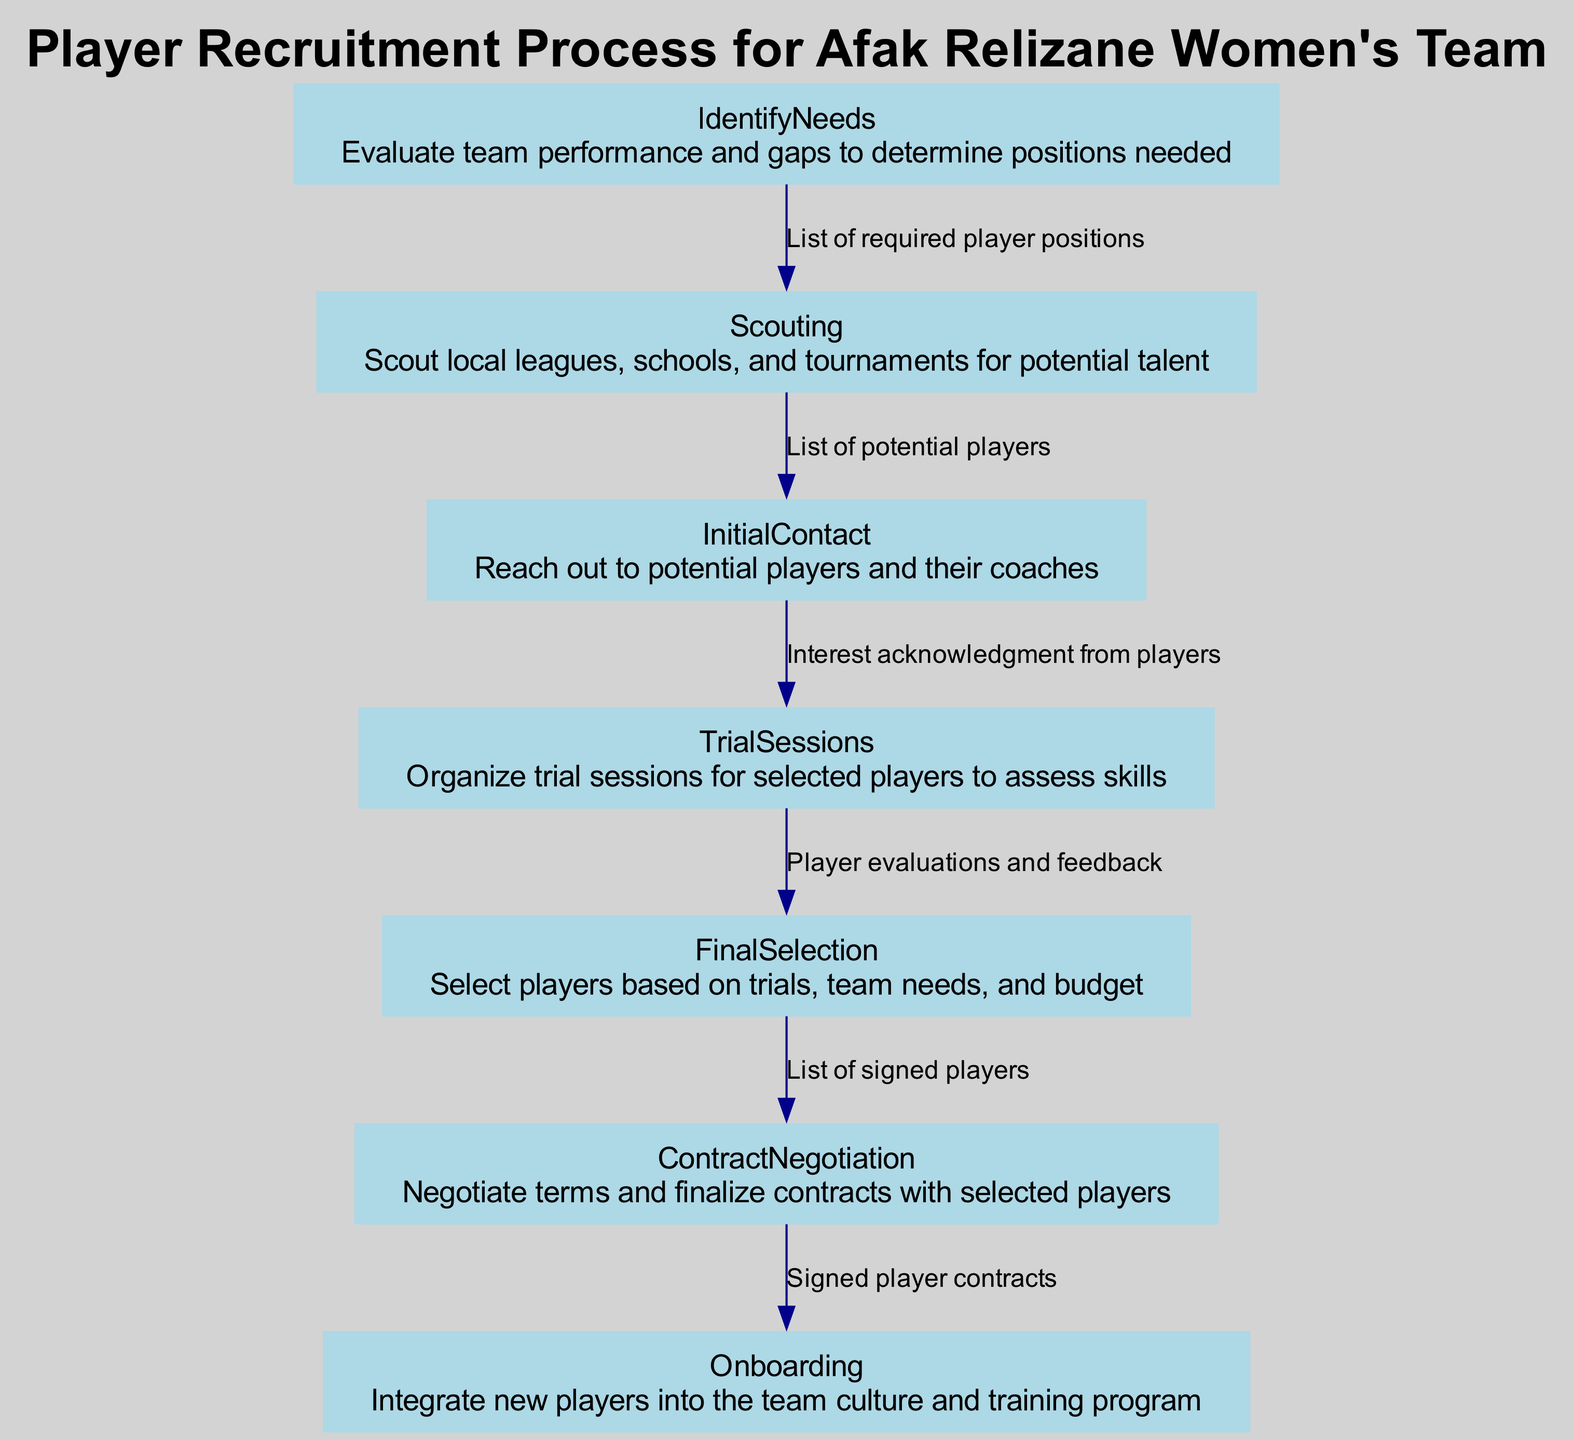what is the first step in the recruitment process? The flow chart begins with "IdentifyNeeds," which is the first step outlined in the player recruitment process.
Answer: IdentifyNeeds how many total steps are there in the recruitment process? By counting the nodes from "IdentifyNeeds" to "Onboarding," there are seven distinct steps in the recruitment process.
Answer: 7 which step comes after "Scouting"? According to the sequence in the flow chart, "InitialContact" is the step that follows "Scouting."
Answer: InitialContact what is the output of the "TrialSessions" step? The output is described as "Player evaluations and feedback," which directly follows the description of the "TrialSessions" step in the diagram.
Answer: Player evaluations and feedback which step is responsible for integrating new players? The step designated for this task is "Onboarding," as indicated in the flow chart.
Answer: Onboarding what is the overall last step in the recruitment process? The recruitment process culminates with "Onboarding," which is the final step shown in this flow chart.
Answer: Onboarding how does "FinalSelection" relate to "TrialSessions"? "FinalSelection" depends on the evaluations and feedback received from the preceding step, "TrialSessions," to select players based on trials, team needs, and budget.
Answer: FinalSelection what is the output of the "ContractNegotiation" step? The output is outlined as "Signed player contracts," indicating the result of the contract negotiation process with selected players.
Answer: Signed player contracts what is the purpose of the "InitialContact" step? The purpose of this step is to reach out to potential players and their coaches, indicated by the description associated with the "InitialContact" in the diagram.
Answer: Reach out to potential players and their coaches 